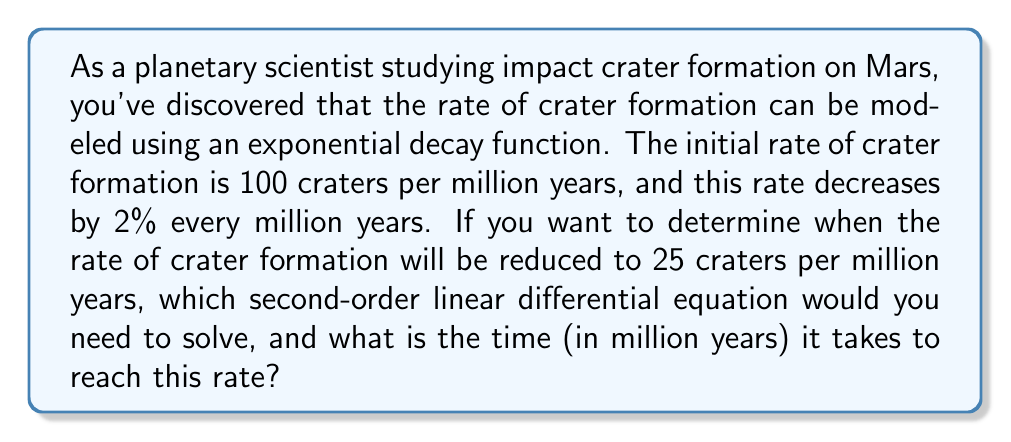Give your solution to this math problem. To solve this problem, we need to set up and solve a second-order linear differential equation. Let's break it down step by step:

1) First, let's define our variables:
   $t$ = time in million years
   $r(t)$ = rate of crater formation at time $t$

2) The initial rate is given as $r(0) = 100$ craters per million years.

3) The rate decreases by 2% every million years. This can be modeled as an exponential decay function:

   $r(t) = 100e^{-0.02t}$

4) We want to find when $r(t) = 25$. So, we need to solve:

   $25 = 100e^{-0.02t}$

5) Dividing both sides by 100:

   $0.25 = e^{-0.02t}$

6) Taking the natural log of both sides:

   $\ln(0.25) = -0.02t$

7) Solving for $t$:

   $t = \frac{\ln(0.25)}{-0.02} = \frac{-1.3862943611198906}{-0.02} \approx 69.31$ million years

8) To form a second-order linear differential equation, we need to differentiate $r(t)$ twice:

   $r'(t) = -2e^{-0.02t}$
   $r''(t) = 0.04e^{-0.02t}$

9) We can now form the second-order linear differential equation:

   $r''(t) - 0.04r'(t) + 0.0004r(t) = 0$

This is the second-order linear differential equation that models the rate of crater formation over time.
Answer: The second-order linear differential equation is:

$$r''(t) - 0.04r'(t) + 0.0004r(t) = 0$$

The time it takes for the rate to reduce to 25 craters per million years is approximately 69.31 million years. 